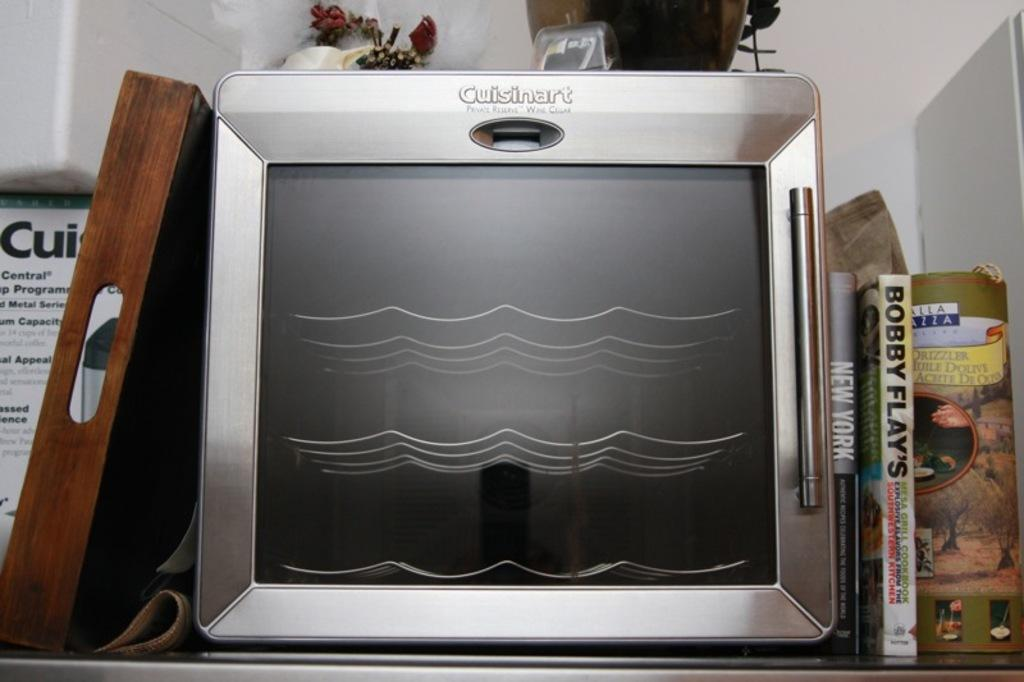<image>
Render a clear and concise summary of the photo. A Cuisinart oven is on a kitchen shelf next to Bobby Flay's cookbooks. 